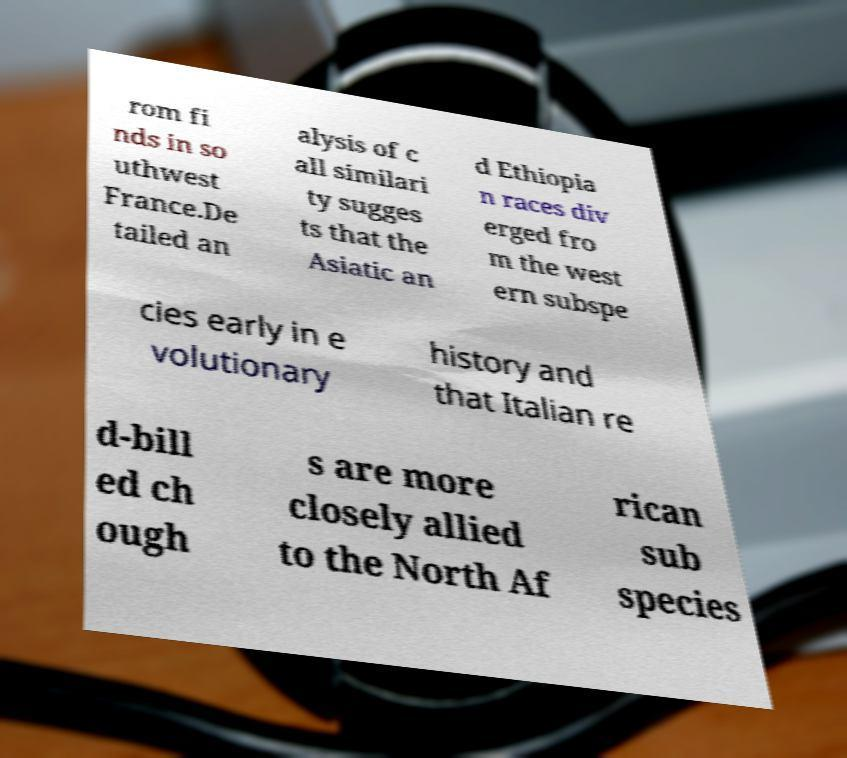What messages or text are displayed in this image? I need them in a readable, typed format. rom fi nds in so uthwest France.De tailed an alysis of c all similari ty sugges ts that the Asiatic an d Ethiopia n races div erged fro m the west ern subspe cies early in e volutionary history and that Italian re d-bill ed ch ough s are more closely allied to the North Af rican sub species 